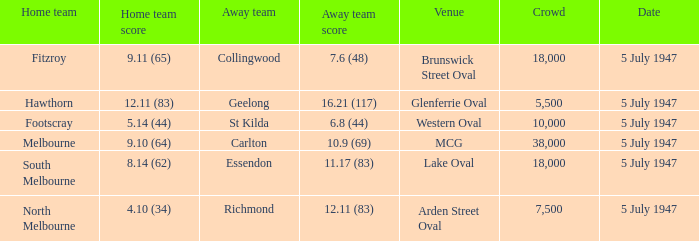What did the home team score when the away team scored 12.11 (83)? 4.10 (34). 